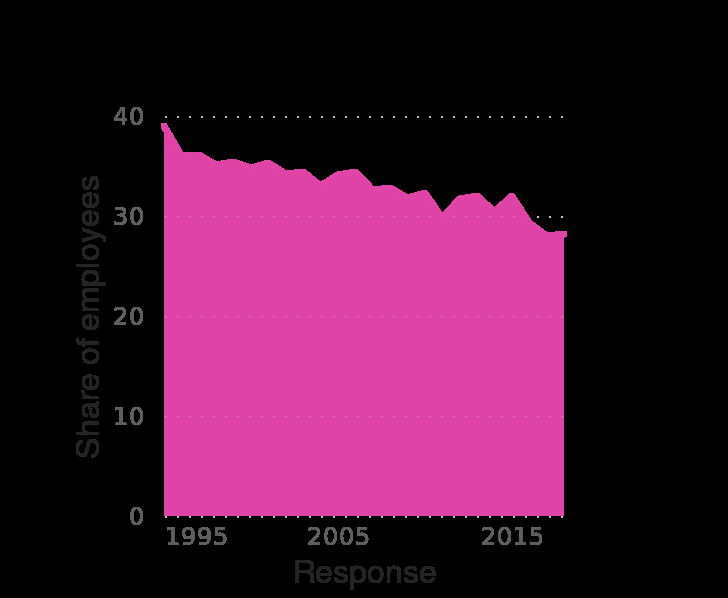<image>
Was the reduction in the employees' share steady or inconsistent? The reduction in the employees' share was steady as time went on. please summary the statistics and relations of the chart The percentage of share the employees got reduced steadily as time went on. 